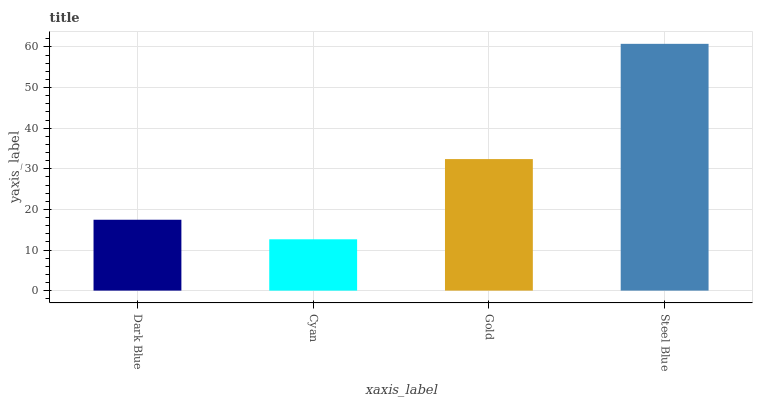Is Cyan the minimum?
Answer yes or no. Yes. Is Steel Blue the maximum?
Answer yes or no. Yes. Is Gold the minimum?
Answer yes or no. No. Is Gold the maximum?
Answer yes or no. No. Is Gold greater than Cyan?
Answer yes or no. Yes. Is Cyan less than Gold?
Answer yes or no. Yes. Is Cyan greater than Gold?
Answer yes or no. No. Is Gold less than Cyan?
Answer yes or no. No. Is Gold the high median?
Answer yes or no. Yes. Is Dark Blue the low median?
Answer yes or no. Yes. Is Cyan the high median?
Answer yes or no. No. Is Steel Blue the low median?
Answer yes or no. No. 